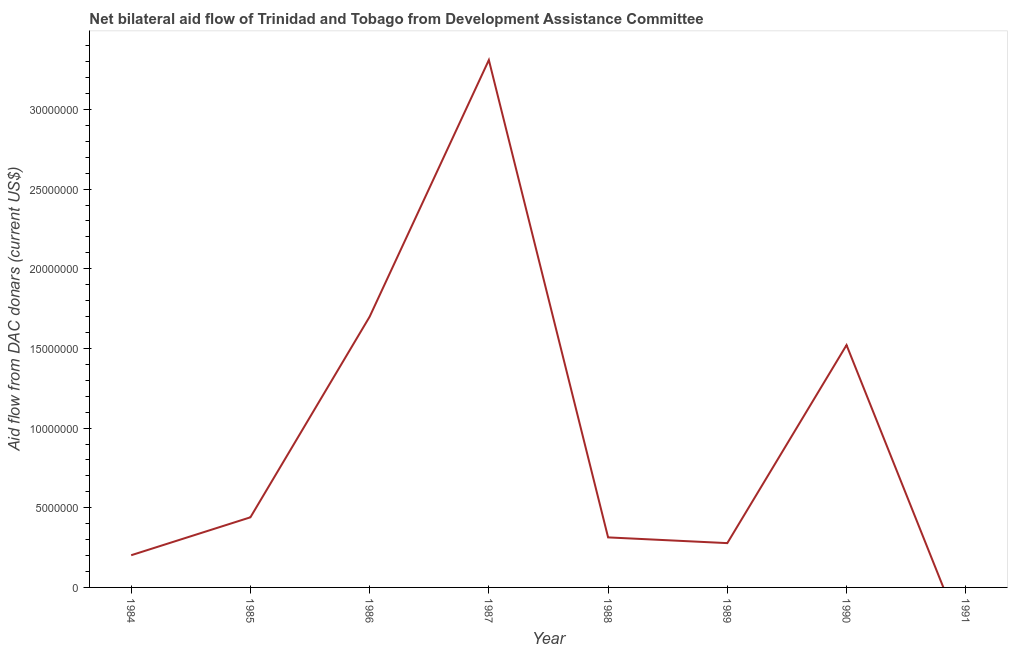What is the net bilateral aid flows from dac donors in 1988?
Provide a short and direct response. 3.14e+06. Across all years, what is the maximum net bilateral aid flows from dac donors?
Your answer should be very brief. 3.31e+07. Across all years, what is the minimum net bilateral aid flows from dac donors?
Your answer should be very brief. 0. What is the sum of the net bilateral aid flows from dac donors?
Your response must be concise. 7.76e+07. What is the difference between the net bilateral aid flows from dac donors in 1985 and 1986?
Provide a succinct answer. -1.26e+07. What is the average net bilateral aid flows from dac donors per year?
Your answer should be compact. 9.70e+06. What is the median net bilateral aid flows from dac donors?
Give a very brief answer. 3.77e+06. What is the ratio of the net bilateral aid flows from dac donors in 1985 to that in 1990?
Keep it short and to the point. 0.29. Is the difference between the net bilateral aid flows from dac donors in 1987 and 1990 greater than the difference between any two years?
Ensure brevity in your answer.  No. What is the difference between the highest and the second highest net bilateral aid flows from dac donors?
Make the answer very short. 1.61e+07. Is the sum of the net bilateral aid flows from dac donors in 1987 and 1988 greater than the maximum net bilateral aid flows from dac donors across all years?
Make the answer very short. Yes. What is the difference between the highest and the lowest net bilateral aid flows from dac donors?
Ensure brevity in your answer.  3.31e+07. How many lines are there?
Make the answer very short. 1. How many years are there in the graph?
Offer a very short reply. 8. Does the graph contain grids?
Make the answer very short. No. What is the title of the graph?
Provide a short and direct response. Net bilateral aid flow of Trinidad and Tobago from Development Assistance Committee. What is the label or title of the Y-axis?
Offer a terse response. Aid flow from DAC donars (current US$). What is the Aid flow from DAC donars (current US$) in 1984?
Offer a very short reply. 2.02e+06. What is the Aid flow from DAC donars (current US$) of 1985?
Provide a short and direct response. 4.40e+06. What is the Aid flow from DAC donars (current US$) in 1986?
Make the answer very short. 1.70e+07. What is the Aid flow from DAC donars (current US$) in 1987?
Keep it short and to the point. 3.31e+07. What is the Aid flow from DAC donars (current US$) in 1988?
Make the answer very short. 3.14e+06. What is the Aid flow from DAC donars (current US$) of 1989?
Your answer should be compact. 2.78e+06. What is the Aid flow from DAC donars (current US$) in 1990?
Offer a terse response. 1.52e+07. What is the Aid flow from DAC donars (current US$) of 1991?
Offer a terse response. 0. What is the difference between the Aid flow from DAC donars (current US$) in 1984 and 1985?
Give a very brief answer. -2.38e+06. What is the difference between the Aid flow from DAC donars (current US$) in 1984 and 1986?
Offer a very short reply. -1.50e+07. What is the difference between the Aid flow from DAC donars (current US$) in 1984 and 1987?
Ensure brevity in your answer.  -3.11e+07. What is the difference between the Aid flow from DAC donars (current US$) in 1984 and 1988?
Offer a terse response. -1.12e+06. What is the difference between the Aid flow from DAC donars (current US$) in 1984 and 1989?
Offer a very short reply. -7.60e+05. What is the difference between the Aid flow from DAC donars (current US$) in 1984 and 1990?
Your answer should be compact. -1.32e+07. What is the difference between the Aid flow from DAC donars (current US$) in 1985 and 1986?
Ensure brevity in your answer.  -1.26e+07. What is the difference between the Aid flow from DAC donars (current US$) in 1985 and 1987?
Provide a short and direct response. -2.87e+07. What is the difference between the Aid flow from DAC donars (current US$) in 1985 and 1988?
Your response must be concise. 1.26e+06. What is the difference between the Aid flow from DAC donars (current US$) in 1985 and 1989?
Make the answer very short. 1.62e+06. What is the difference between the Aid flow from DAC donars (current US$) in 1985 and 1990?
Ensure brevity in your answer.  -1.08e+07. What is the difference between the Aid flow from DAC donars (current US$) in 1986 and 1987?
Offer a terse response. -1.61e+07. What is the difference between the Aid flow from DAC donars (current US$) in 1986 and 1988?
Provide a succinct answer. 1.38e+07. What is the difference between the Aid flow from DAC donars (current US$) in 1986 and 1989?
Keep it short and to the point. 1.42e+07. What is the difference between the Aid flow from DAC donars (current US$) in 1986 and 1990?
Make the answer very short. 1.78e+06. What is the difference between the Aid flow from DAC donars (current US$) in 1987 and 1988?
Make the answer very short. 3.00e+07. What is the difference between the Aid flow from DAC donars (current US$) in 1987 and 1989?
Keep it short and to the point. 3.03e+07. What is the difference between the Aid flow from DAC donars (current US$) in 1987 and 1990?
Your answer should be compact. 1.79e+07. What is the difference between the Aid flow from DAC donars (current US$) in 1988 and 1989?
Give a very brief answer. 3.60e+05. What is the difference between the Aid flow from DAC donars (current US$) in 1988 and 1990?
Your answer should be compact. -1.21e+07. What is the difference between the Aid flow from DAC donars (current US$) in 1989 and 1990?
Give a very brief answer. -1.24e+07. What is the ratio of the Aid flow from DAC donars (current US$) in 1984 to that in 1985?
Offer a terse response. 0.46. What is the ratio of the Aid flow from DAC donars (current US$) in 1984 to that in 1986?
Give a very brief answer. 0.12. What is the ratio of the Aid flow from DAC donars (current US$) in 1984 to that in 1987?
Offer a terse response. 0.06. What is the ratio of the Aid flow from DAC donars (current US$) in 1984 to that in 1988?
Your response must be concise. 0.64. What is the ratio of the Aid flow from DAC donars (current US$) in 1984 to that in 1989?
Your answer should be very brief. 0.73. What is the ratio of the Aid flow from DAC donars (current US$) in 1984 to that in 1990?
Keep it short and to the point. 0.13. What is the ratio of the Aid flow from DAC donars (current US$) in 1985 to that in 1986?
Ensure brevity in your answer.  0.26. What is the ratio of the Aid flow from DAC donars (current US$) in 1985 to that in 1987?
Provide a short and direct response. 0.13. What is the ratio of the Aid flow from DAC donars (current US$) in 1985 to that in 1988?
Offer a very short reply. 1.4. What is the ratio of the Aid flow from DAC donars (current US$) in 1985 to that in 1989?
Your answer should be very brief. 1.58. What is the ratio of the Aid flow from DAC donars (current US$) in 1985 to that in 1990?
Your answer should be very brief. 0.29. What is the ratio of the Aid flow from DAC donars (current US$) in 1986 to that in 1987?
Provide a succinct answer. 0.51. What is the ratio of the Aid flow from DAC donars (current US$) in 1986 to that in 1988?
Give a very brief answer. 5.41. What is the ratio of the Aid flow from DAC donars (current US$) in 1986 to that in 1989?
Keep it short and to the point. 6.11. What is the ratio of the Aid flow from DAC donars (current US$) in 1986 to that in 1990?
Give a very brief answer. 1.12. What is the ratio of the Aid flow from DAC donars (current US$) in 1987 to that in 1988?
Provide a short and direct response. 10.54. What is the ratio of the Aid flow from DAC donars (current US$) in 1987 to that in 1989?
Make the answer very short. 11.91. What is the ratio of the Aid flow from DAC donars (current US$) in 1987 to that in 1990?
Your response must be concise. 2.18. What is the ratio of the Aid flow from DAC donars (current US$) in 1988 to that in 1989?
Keep it short and to the point. 1.13. What is the ratio of the Aid flow from DAC donars (current US$) in 1988 to that in 1990?
Your answer should be very brief. 0.21. What is the ratio of the Aid flow from DAC donars (current US$) in 1989 to that in 1990?
Your answer should be compact. 0.18. 